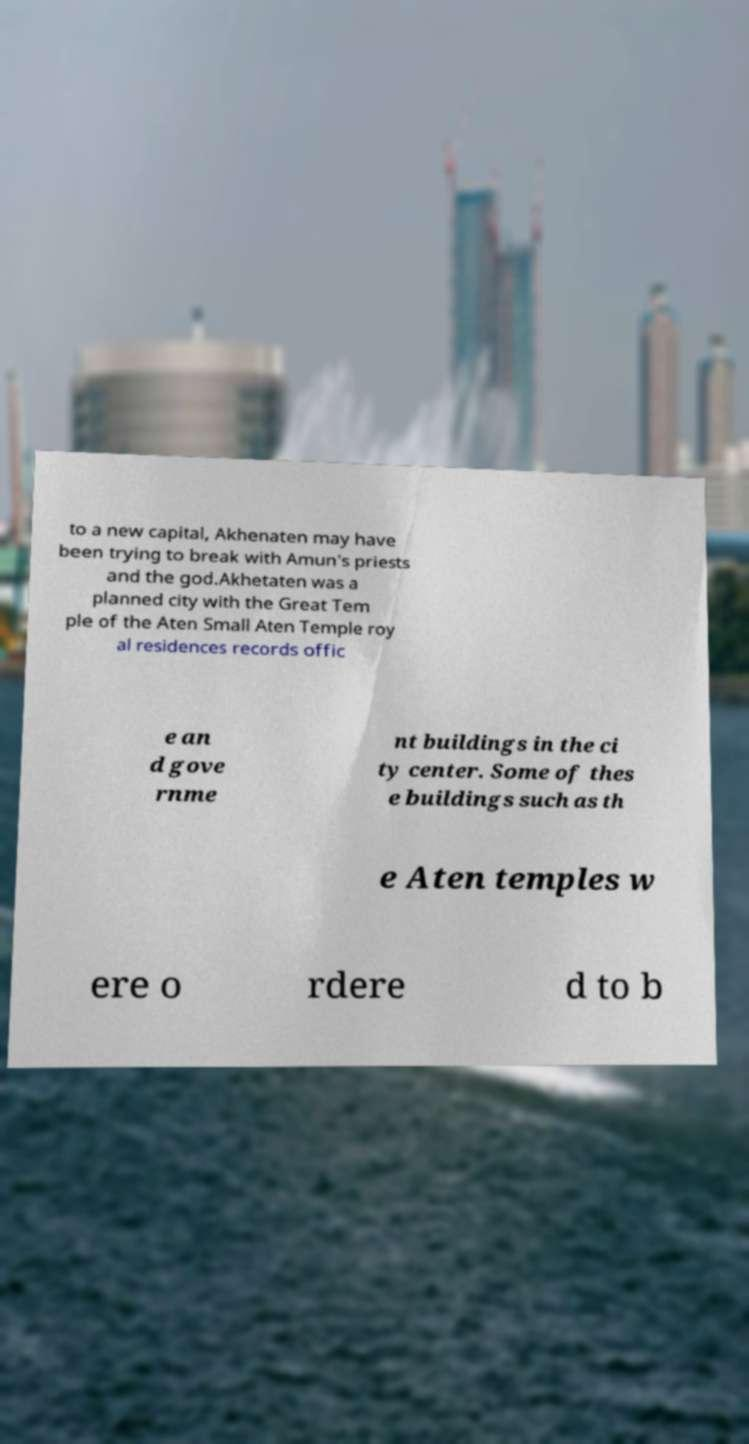There's text embedded in this image that I need extracted. Can you transcribe it verbatim? to a new capital, Akhenaten may have been trying to break with Amun's priests and the god.Akhetaten was a planned city with the Great Tem ple of the Aten Small Aten Temple roy al residences records offic e an d gove rnme nt buildings in the ci ty center. Some of thes e buildings such as th e Aten temples w ere o rdere d to b 